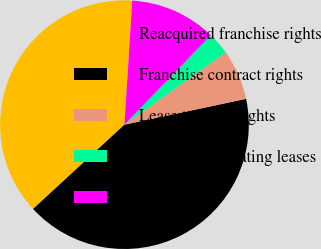Convert chart to OTSL. <chart><loc_0><loc_0><loc_500><loc_500><pie_chart><fcel>Reacquired franchise rights<fcel>Franchise contract rights<fcel>Lease tenancy rights<fcel>Favorable operating leases<fcel>Other<nl><fcel>37.85%<fcel>41.47%<fcel>6.53%<fcel>2.91%<fcel>11.23%<nl></chart> 